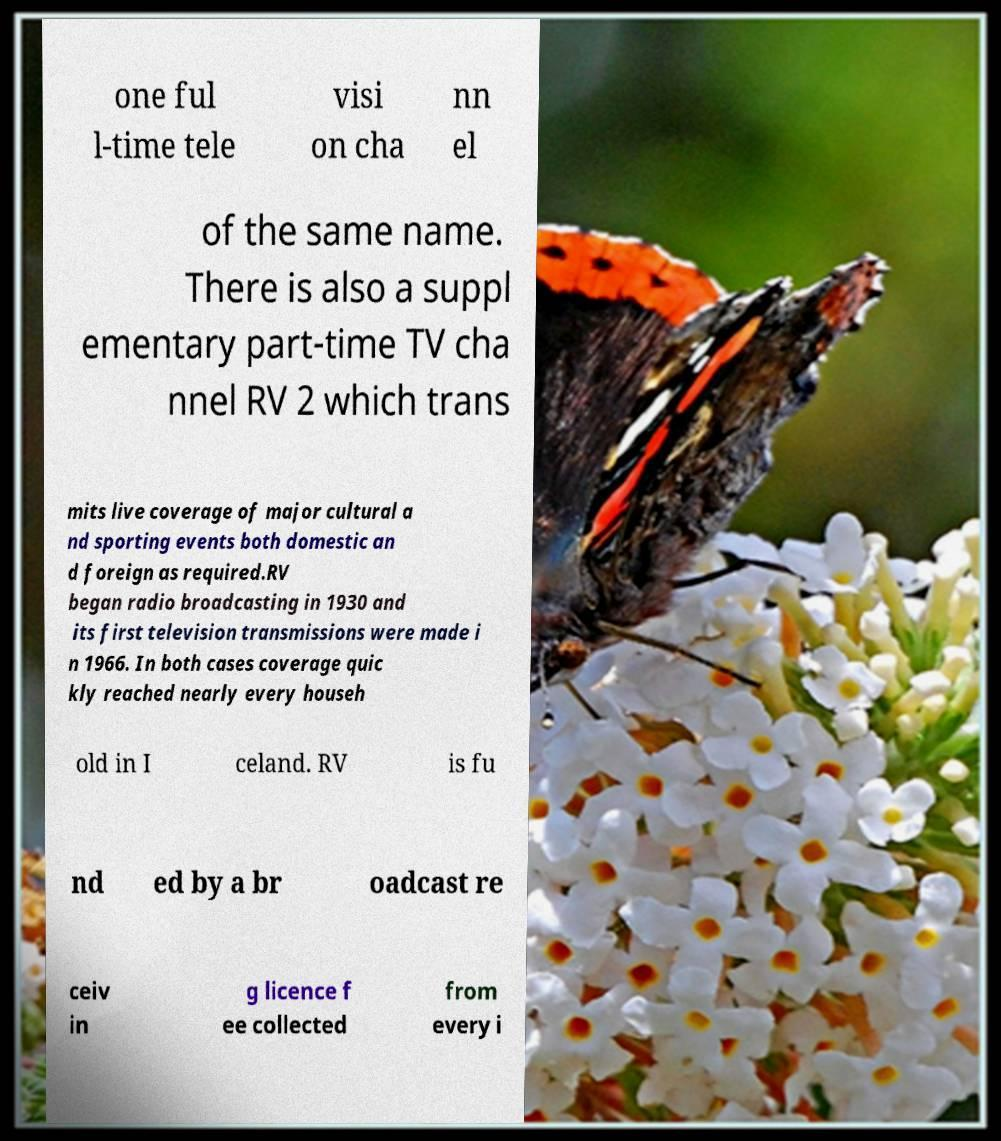Can you accurately transcribe the text from the provided image for me? one ful l-time tele visi on cha nn el of the same name. There is also a suppl ementary part-time TV cha nnel RV 2 which trans mits live coverage of major cultural a nd sporting events both domestic an d foreign as required.RV began radio broadcasting in 1930 and its first television transmissions were made i n 1966. In both cases coverage quic kly reached nearly every househ old in I celand. RV is fu nd ed by a br oadcast re ceiv in g licence f ee collected from every i 